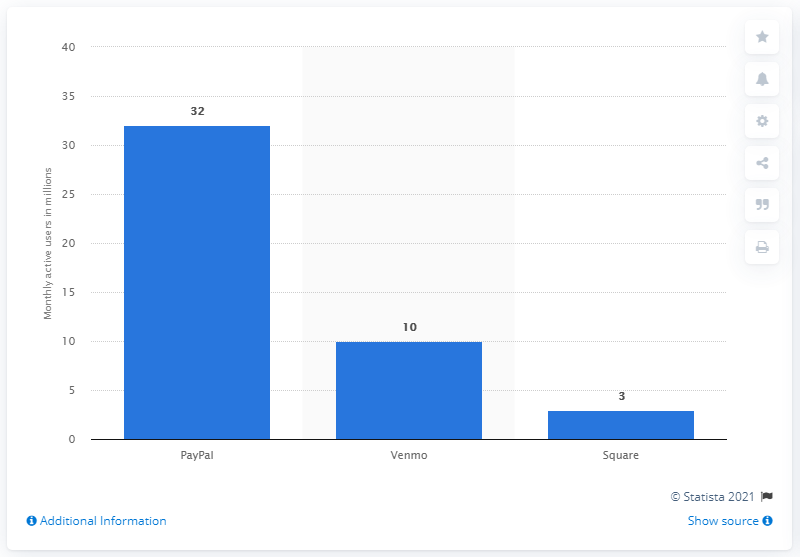Give some essential details in this illustration. PayPal's monthly mobile app users were 32 at the time. 